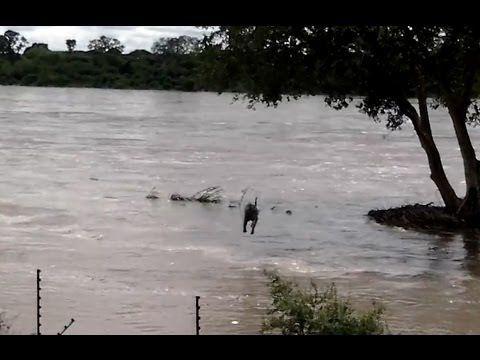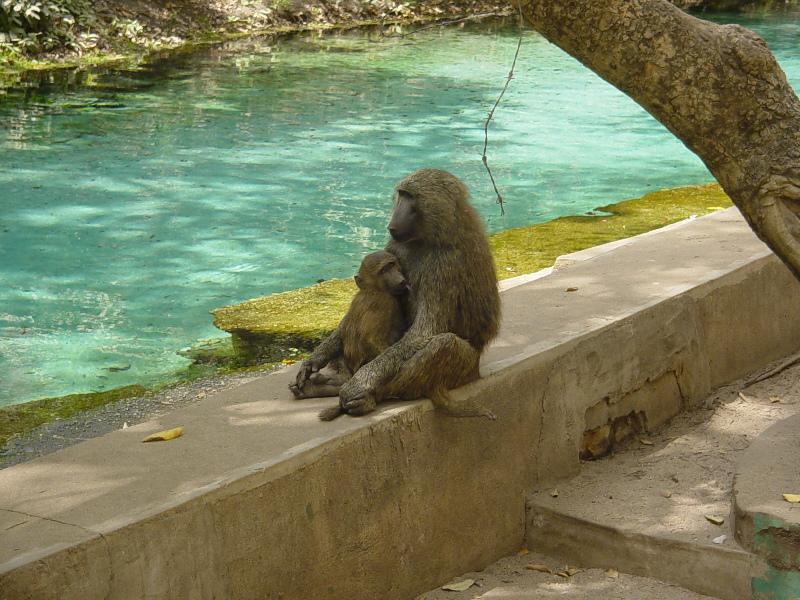The first image is the image on the left, the second image is the image on the right. Evaluate the accuracy of this statement regarding the images: "An image includes a baboon sitting on a manmade ledge of a pool.". Is it true? Answer yes or no. Yes. The first image is the image on the left, the second image is the image on the right. Given the left and right images, does the statement "An animal in the image on the right is sitting on a concrete railing." hold true? Answer yes or no. Yes. 